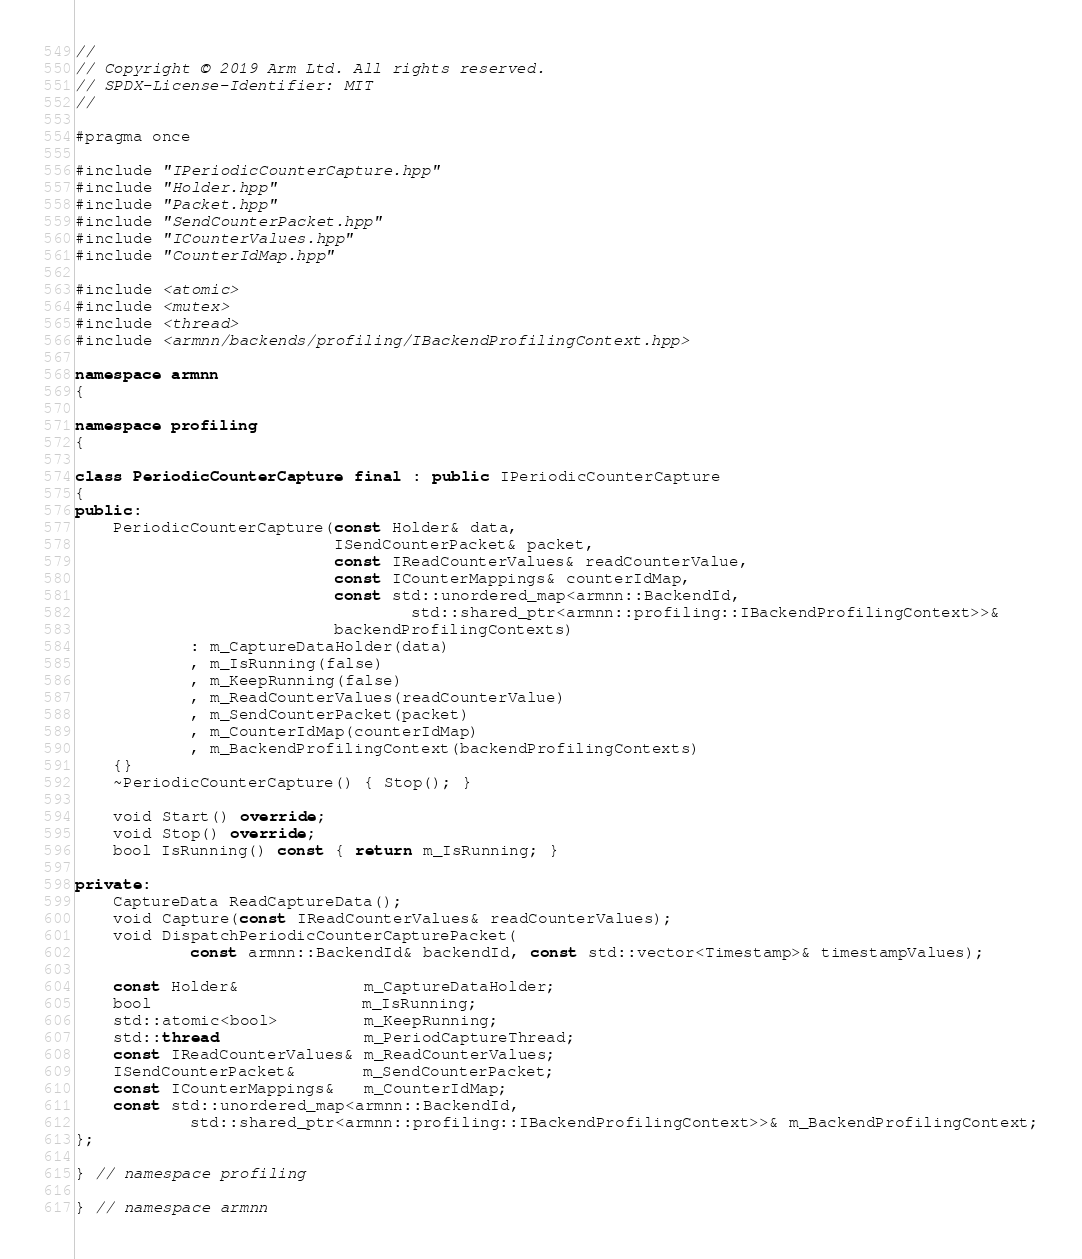Convert code to text. <code><loc_0><loc_0><loc_500><loc_500><_C++_>//
// Copyright © 2019 Arm Ltd. All rights reserved.
// SPDX-License-Identifier: MIT
//

#pragma once

#include "IPeriodicCounterCapture.hpp"
#include "Holder.hpp"
#include "Packet.hpp"
#include "SendCounterPacket.hpp"
#include "ICounterValues.hpp"
#include "CounterIdMap.hpp"

#include <atomic>
#include <mutex>
#include <thread>
#include <armnn/backends/profiling/IBackendProfilingContext.hpp>

namespace armnn
{

namespace profiling
{

class PeriodicCounterCapture final : public IPeriodicCounterCapture
{
public:
    PeriodicCounterCapture(const Holder& data,
                           ISendCounterPacket& packet,
                           const IReadCounterValues& readCounterValue,
                           const ICounterMappings& counterIdMap,
                           const std::unordered_map<armnn::BackendId,
                                   std::shared_ptr<armnn::profiling::IBackendProfilingContext>>&
                           backendProfilingContexts)
            : m_CaptureDataHolder(data)
            , m_IsRunning(false)
            , m_KeepRunning(false)
            , m_ReadCounterValues(readCounterValue)
            , m_SendCounterPacket(packet)
            , m_CounterIdMap(counterIdMap)
            , m_BackendProfilingContext(backendProfilingContexts)
    {}
    ~PeriodicCounterCapture() { Stop(); }

    void Start() override;
    void Stop() override;
    bool IsRunning() const { return m_IsRunning; }

private:
    CaptureData ReadCaptureData();
    void Capture(const IReadCounterValues& readCounterValues);
    void DispatchPeriodicCounterCapturePacket(
            const armnn::BackendId& backendId, const std::vector<Timestamp>& timestampValues);

    const Holder&             m_CaptureDataHolder;
    bool                      m_IsRunning;
    std::atomic<bool>         m_KeepRunning;
    std::thread               m_PeriodCaptureThread;
    const IReadCounterValues& m_ReadCounterValues;
    ISendCounterPacket&       m_SendCounterPacket;
    const ICounterMappings&   m_CounterIdMap;
    const std::unordered_map<armnn::BackendId,
            std::shared_ptr<armnn::profiling::IBackendProfilingContext>>& m_BackendProfilingContext;
};

} // namespace profiling

} // namespace armnn
</code> 